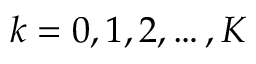<formula> <loc_0><loc_0><loc_500><loc_500>k = 0 , 1 , 2 , \dots , K</formula> 